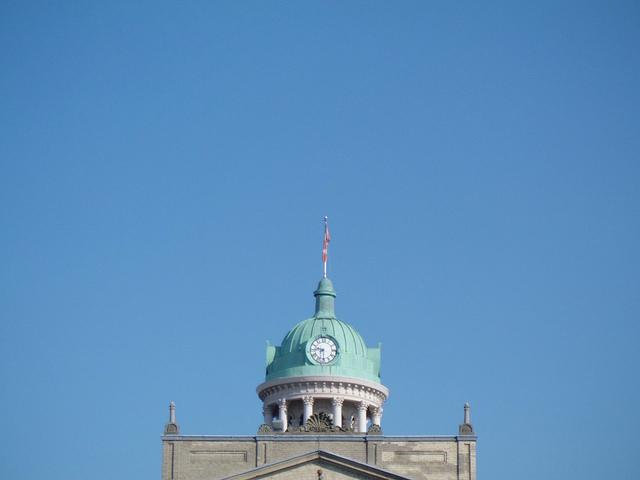Where is the clock?
Keep it brief. On tower. Why style of architecture is in the photo?
Quick response, please. Gothic. What time is it?
Short answer required. 9:30. What is on the very top of the building?
Keep it brief. Flag. 